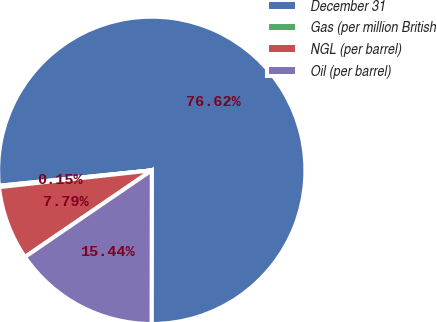Convert chart. <chart><loc_0><loc_0><loc_500><loc_500><pie_chart><fcel>December 31<fcel>Gas (per million British<fcel>NGL (per barrel)<fcel>Oil (per barrel)<nl><fcel>76.62%<fcel>0.15%<fcel>7.79%<fcel>15.44%<nl></chart> 